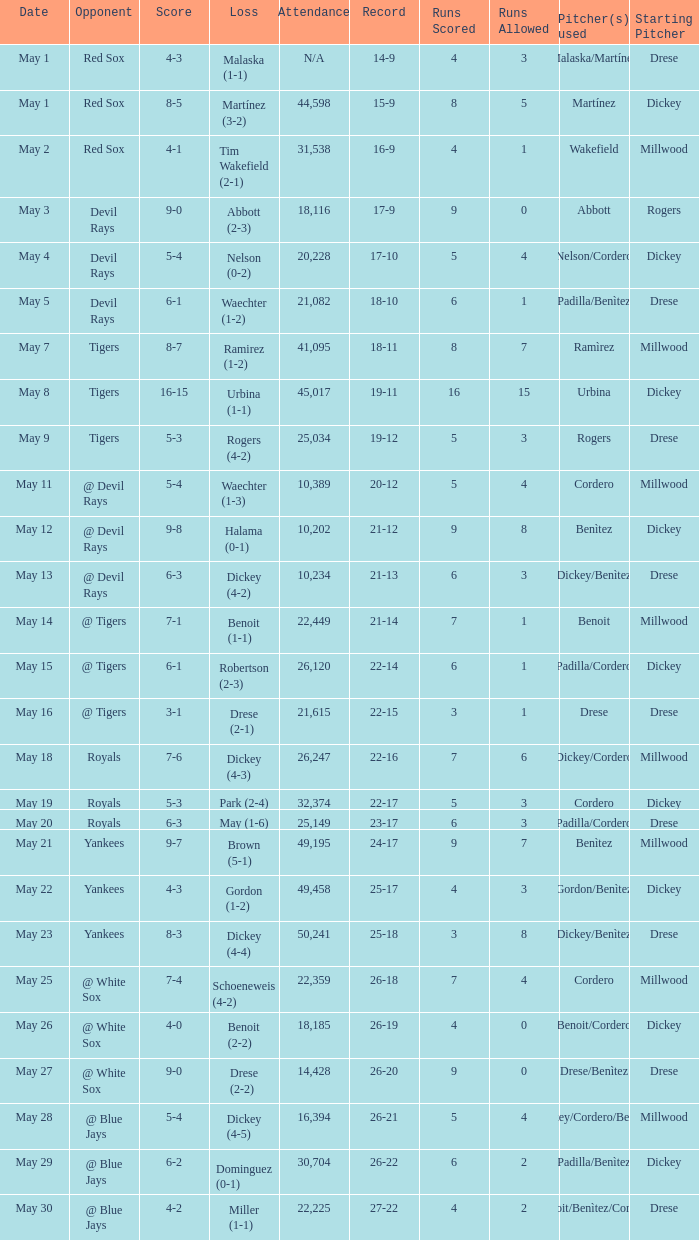What is the score of the game attended by 25,034? 5-3. 